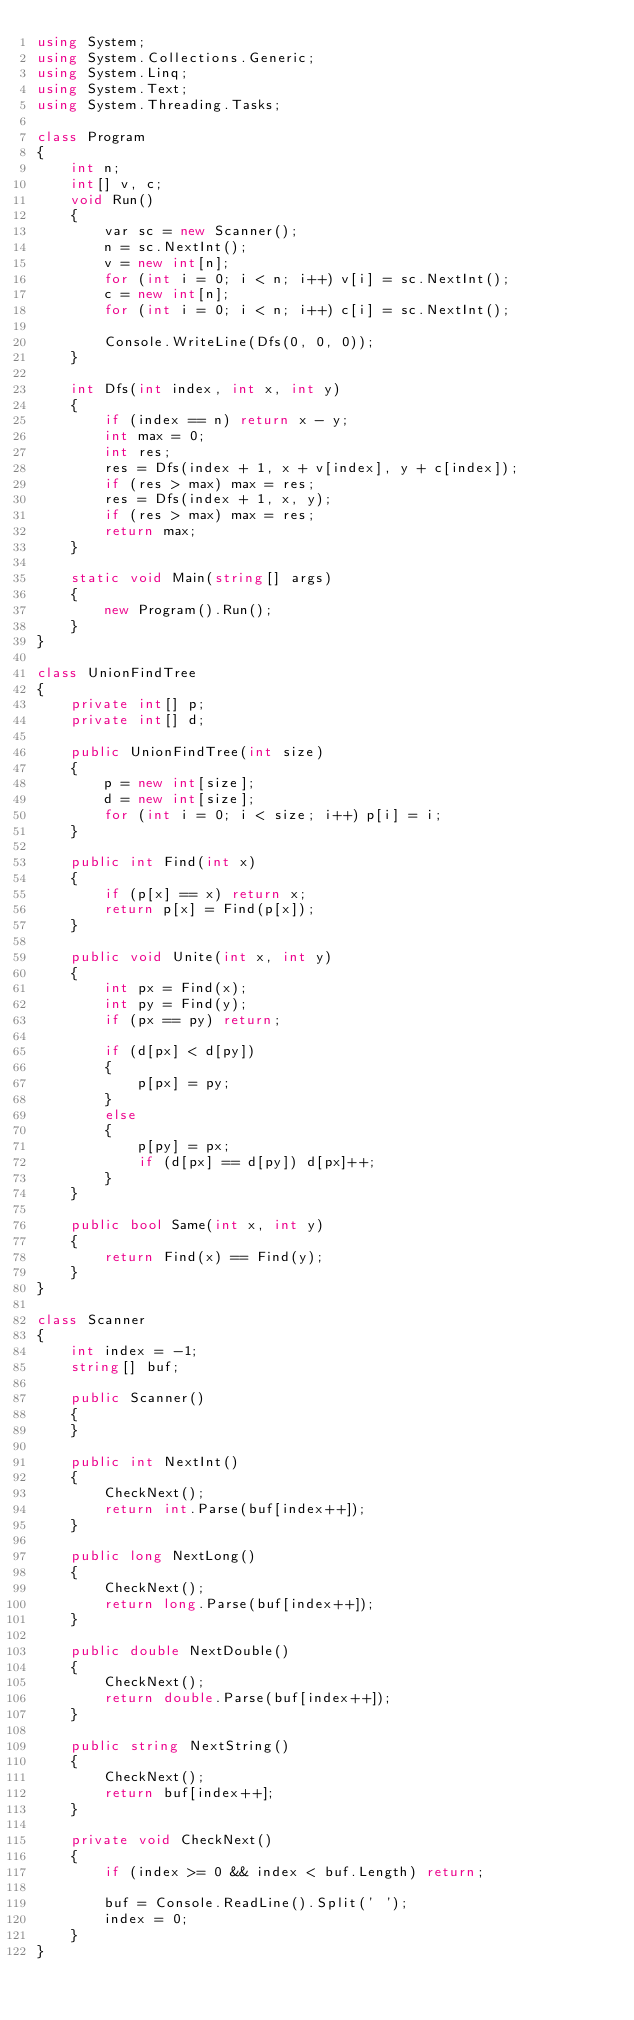<code> <loc_0><loc_0><loc_500><loc_500><_C#_>using System;
using System.Collections.Generic;
using System.Linq;
using System.Text;
using System.Threading.Tasks;

class Program
{
    int n;
    int[] v, c;
    void Run()
    {
        var sc = new Scanner();
        n = sc.NextInt();
        v = new int[n];
        for (int i = 0; i < n; i++) v[i] = sc.NextInt();
        c = new int[n];
        for (int i = 0; i < n; i++) c[i] = sc.NextInt();

        Console.WriteLine(Dfs(0, 0, 0));
    }

    int Dfs(int index, int x, int y)
    {
        if (index == n) return x - y;
        int max = 0;
        int res;
        res = Dfs(index + 1, x + v[index], y + c[index]);
        if (res > max) max = res;
        res = Dfs(index + 1, x, y);
        if (res > max) max = res;
        return max;
    }

    static void Main(string[] args)
    {
        new Program().Run();
    }
}

class UnionFindTree
{
    private int[] p;
    private int[] d;

    public UnionFindTree(int size)
    {
        p = new int[size];
        d = new int[size];
        for (int i = 0; i < size; i++) p[i] = i;
    }

    public int Find(int x)
    {
        if (p[x] == x) return x;
        return p[x] = Find(p[x]);
    }

    public void Unite(int x, int y)
    {
        int px = Find(x);
        int py = Find(y);
        if (px == py) return;

        if (d[px] < d[py])
        {
            p[px] = py;
        }
        else
        {
            p[py] = px;
            if (d[px] == d[py]) d[px]++;
        }
    }

    public bool Same(int x, int y)
    {
        return Find(x) == Find(y);
    }
}

class Scanner
{
    int index = -1;
    string[] buf;

    public Scanner()
    {
    }

    public int NextInt()
    {
        CheckNext();
        return int.Parse(buf[index++]);
    }

    public long NextLong()
    {
        CheckNext();
        return long.Parse(buf[index++]);
    }

    public double NextDouble()
    {
        CheckNext();
        return double.Parse(buf[index++]);
    }

    public string NextString()
    {
        CheckNext();
        return buf[index++];
    }

    private void CheckNext()
    {
        if (index >= 0 && index < buf.Length) return;

        buf = Console.ReadLine().Split(' ');
        index = 0;
    }
}
</code> 